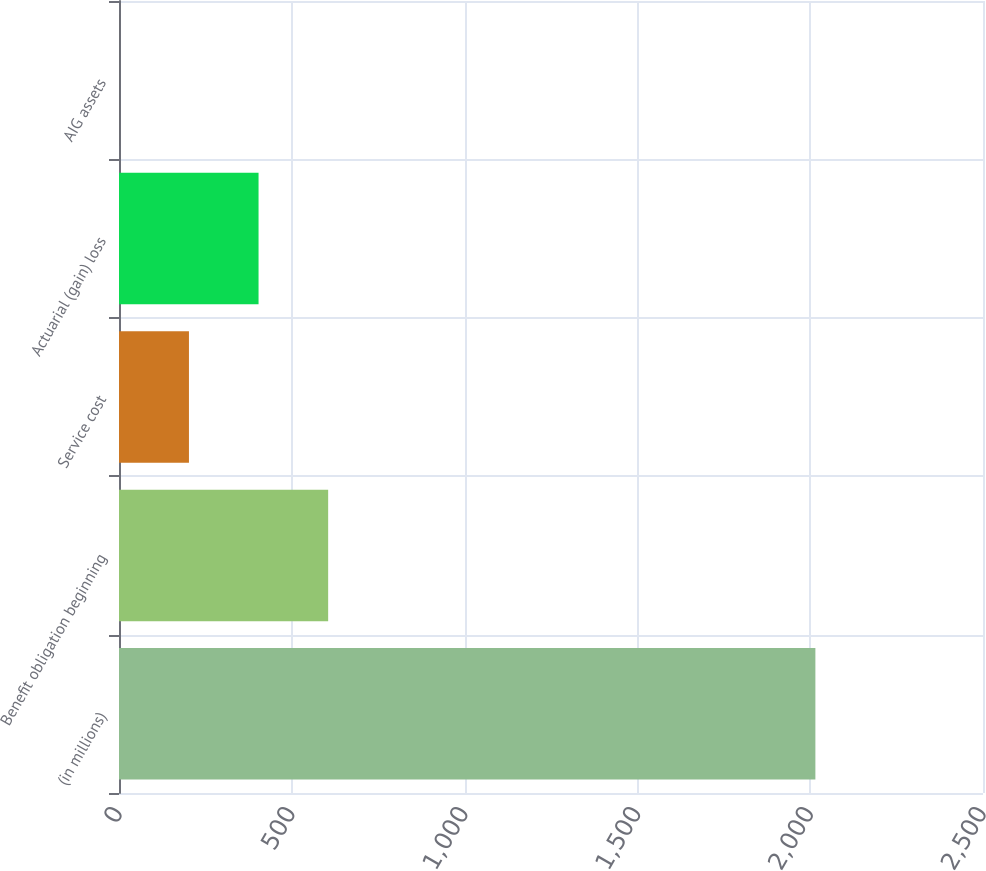Convert chart. <chart><loc_0><loc_0><loc_500><loc_500><bar_chart><fcel>(in millions)<fcel>Benefit obligation beginning<fcel>Service cost<fcel>Actuarial (gain) loss<fcel>AIG assets<nl><fcel>2015<fcel>605.2<fcel>202.4<fcel>403.8<fcel>1<nl></chart> 